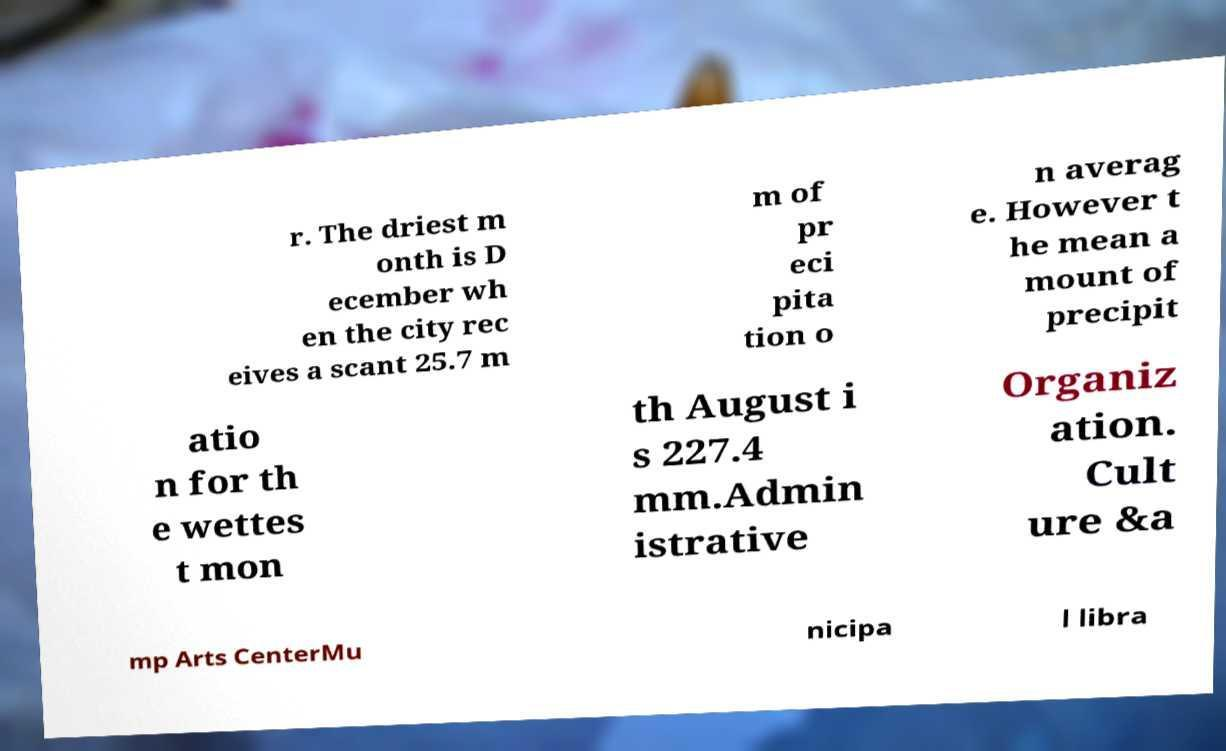I need the written content from this picture converted into text. Can you do that? r. The driest m onth is D ecember wh en the city rec eives a scant 25.7 m m of pr eci pita tion o n averag e. However t he mean a mount of precipit atio n for th e wettes t mon th August i s 227.4 mm.Admin istrative Organiz ation. Cult ure &a mp Arts CenterMu nicipa l libra 